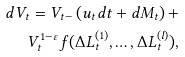Convert formula to latex. <formula><loc_0><loc_0><loc_500><loc_500>d V _ { t } = V _ { t - } \left ( u _ { t } d t + d M _ { t } \right ) + \\ V _ { t } ^ { 1 - \varepsilon } f ( \Delta L ^ { ( 1 ) } _ { t } , \dots , \Delta L ^ { ( l ) } _ { t } ) ,</formula> 